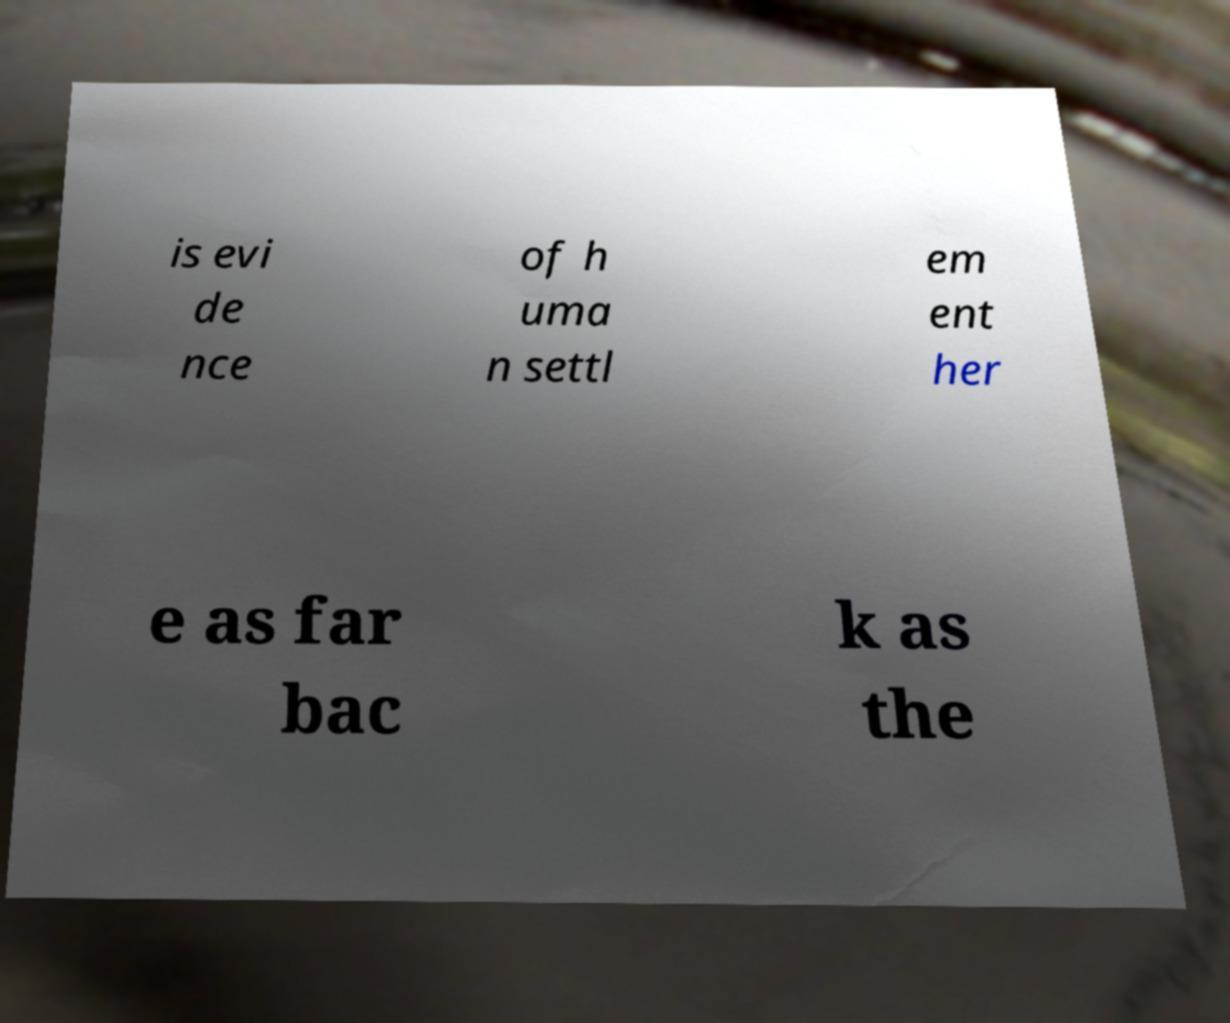Could you extract and type out the text from this image? is evi de nce of h uma n settl em ent her e as far bac k as the 